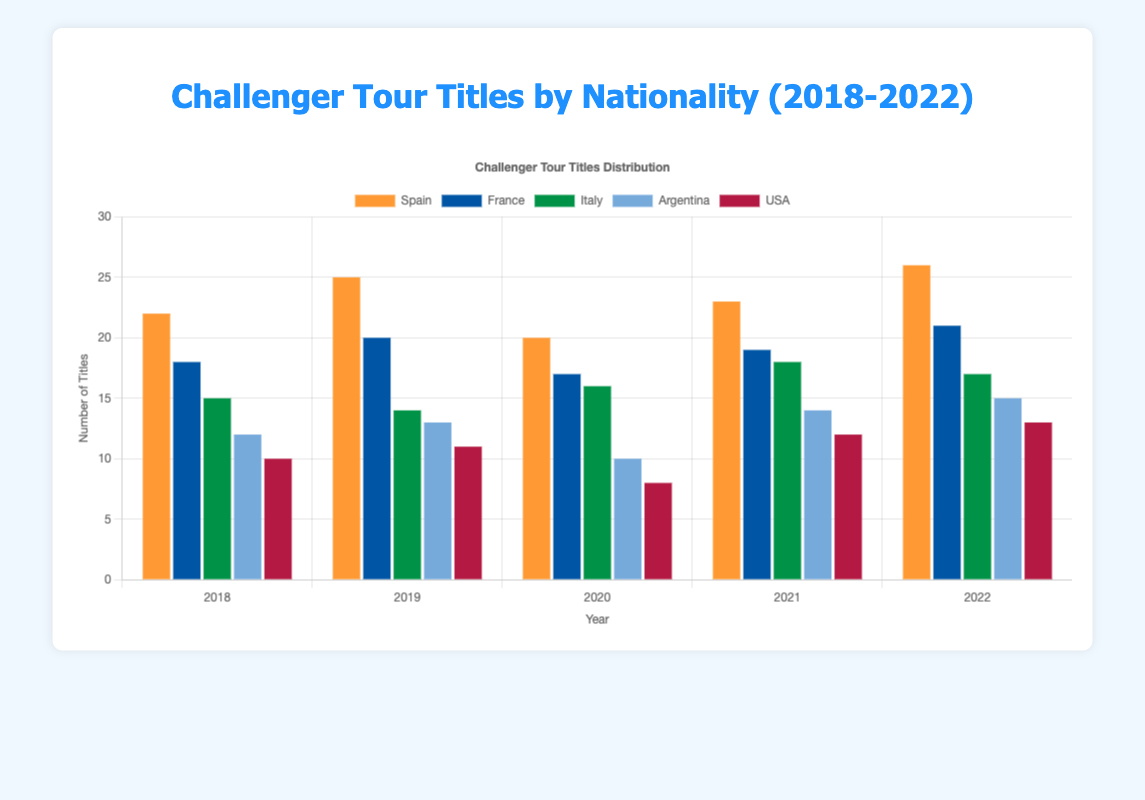What was the total number of Challenger Tour titles won by Spain over the last five years? To find the total number of Challenger Tour titles won by Spain from 2018 to 2022, sum the number of titles each year: 22 (2018) + 25 (2019) + 20 (2020) + 23 (2021) + 26 (2022). The total is 116.
Answer: 116 Which country had the highest number of titles in 2020? Looking at the bar heights for 2020, Spain has the tallest bar, indicating the highest number of titles, which was 20.
Answer: Spain What is the difference in the number of titles between France and Argentina in 2019? In 2019, France won 20 titles and Argentina won 13 titles. To find the difference, subtract the smaller number from the larger: 20 - 13 = 7.
Answer: 7 How did Italy's performance in terms of titles in 2022 compare to 2018? In 2022, Italy won 17 titles, while in 2018, Italy won 15 titles. Thus, Italy won 2 more titles in 2022 compared to 2018.
Answer: 2 more Which countries' titles increased every consecutive year from 2018 to 2022? By checking the data for each year, no country consistently increased its titles every consecutive year from 2018 to 2022.
Answer: None How many total Challenger Tour titles were won by France over all five years? Add up the number of titles won by France each year from 2018 to 2022: 18 + 20 + 17 + 19 + 21. The total is 95.
Answer: 95 Who had more titles in 2021, USA or Argentina? In 2021, Argentina won 14 titles and USA won 12 titles. Argentina had more titles than USA.
Answer: Argentina Which country showed the highest single-year increase in titles, and by how much? Comparing the year-over-year changes for each country, Spain had the largest single-year increase, going from 23 titles in 2021 to 26 titles in 2022, an increase of 3.
Answer: Spain, 3 titles Was there any year where Spain had the same number of titles as France? No, there is no year where Spain and France had the same number of titles within the given data.
Answer: No What is the average number of titles won by USA per year over this period? Sum the number of titles won by USA over the five years: 10 + 11 + 8 + 12 + 13 = 54. Then, divide by 5 to find the average: 54 / 5 = 10.8.
Answer: 10.8 